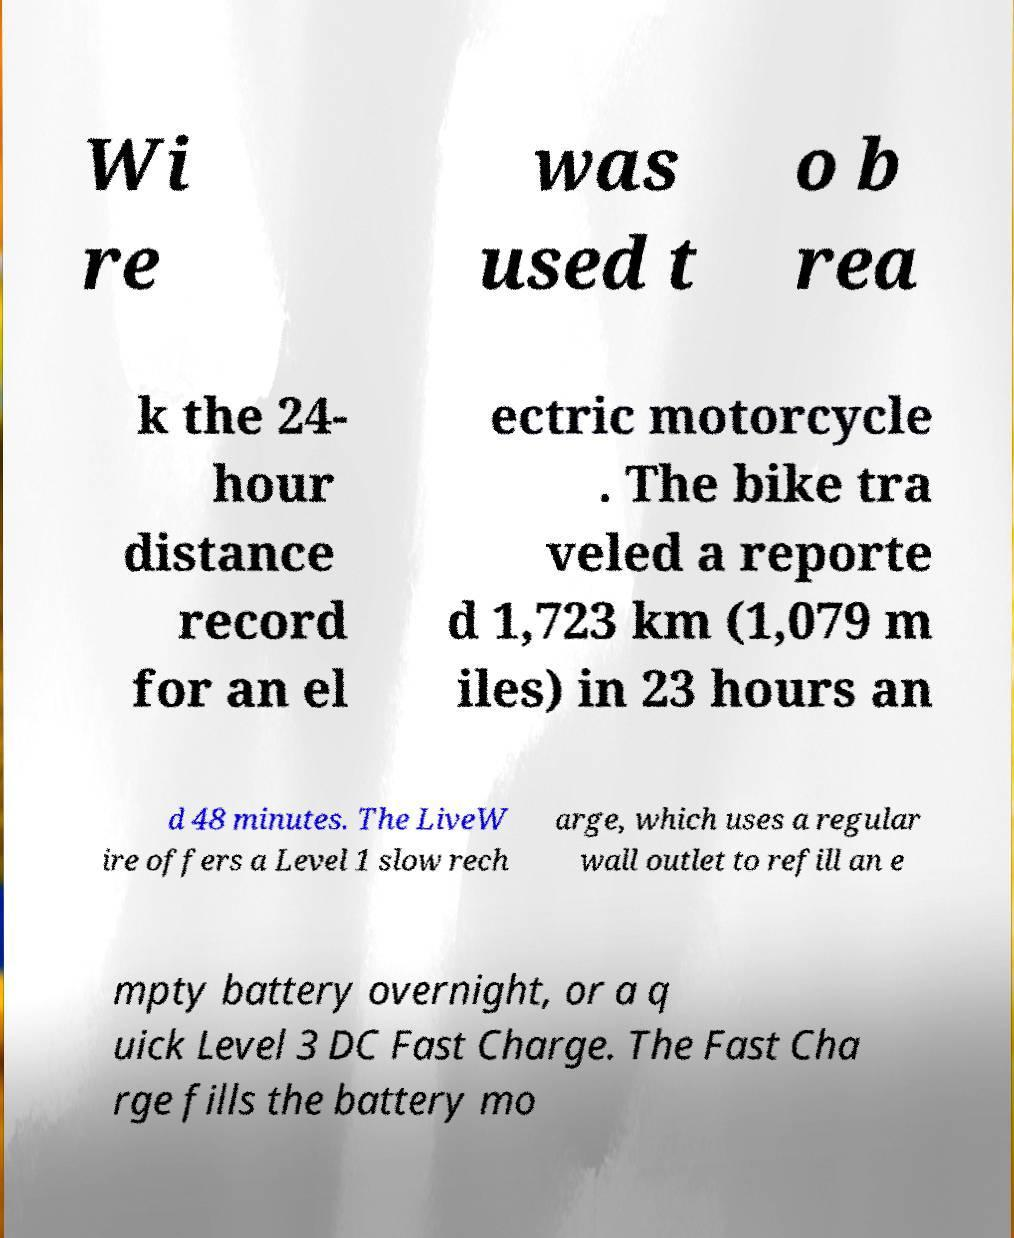Please read and relay the text visible in this image. What does it say? Wi re was used t o b rea k the 24- hour distance record for an el ectric motorcycle . The bike tra veled a reporte d 1,723 km (1,079 m iles) in 23 hours an d 48 minutes. The LiveW ire offers a Level 1 slow rech arge, which uses a regular wall outlet to refill an e mpty battery overnight, or a q uick Level 3 DC Fast Charge. The Fast Cha rge fills the battery mo 